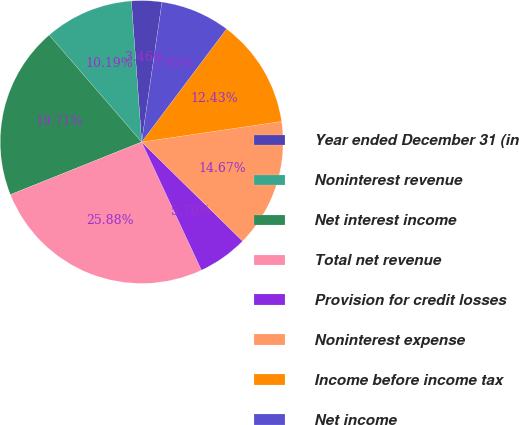<chart> <loc_0><loc_0><loc_500><loc_500><pie_chart><fcel>Year ended December 31 (in<fcel>Noninterest revenue<fcel>Net interest income<fcel>Total net revenue<fcel>Provision for credit losses<fcel>Noninterest expense<fcel>Income before income tax<fcel>Net income<nl><fcel>3.46%<fcel>10.19%<fcel>19.71%<fcel>25.88%<fcel>5.7%<fcel>14.67%<fcel>12.43%<fcel>7.95%<nl></chart> 